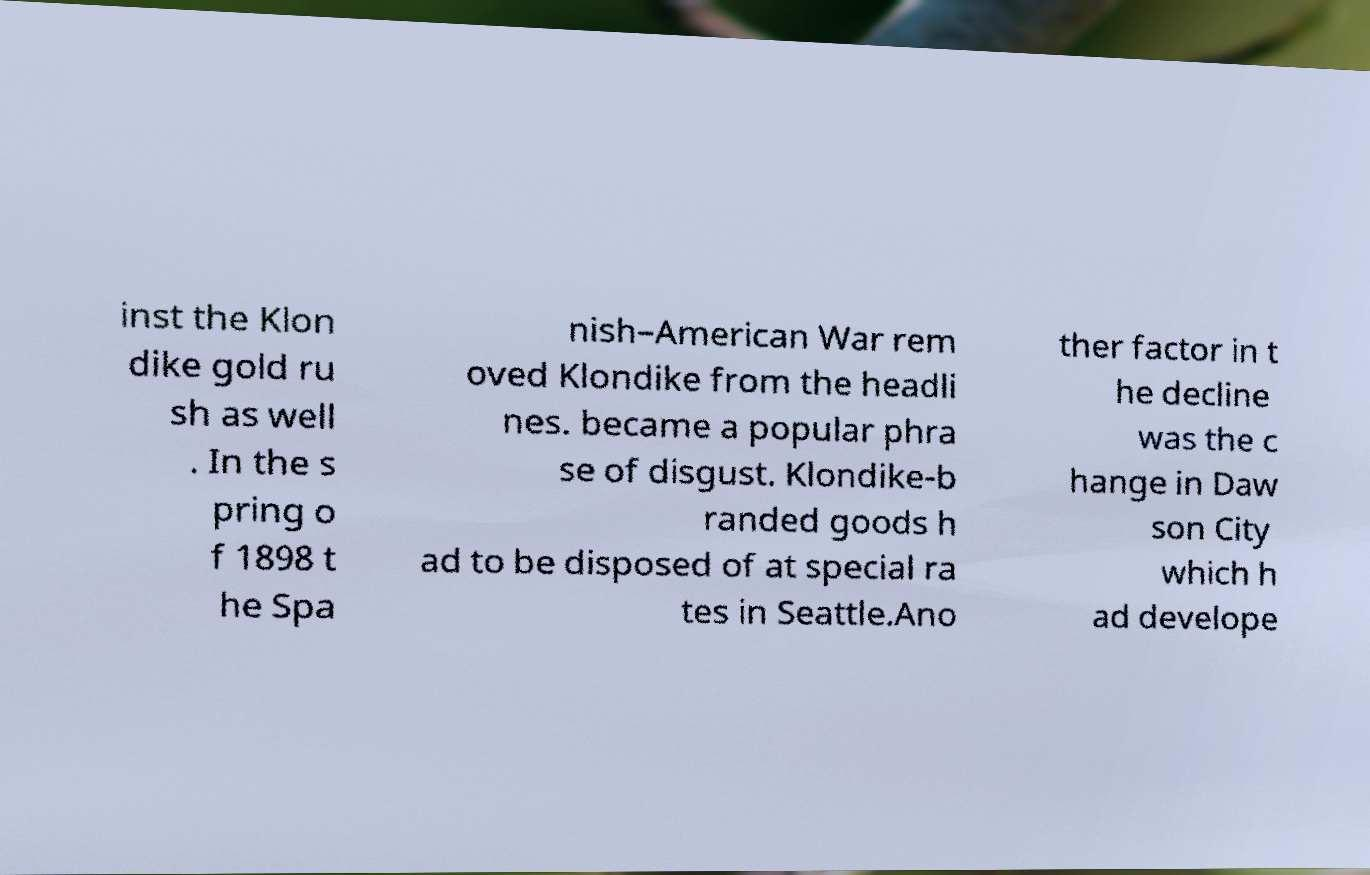Please identify and transcribe the text found in this image. inst the Klon dike gold ru sh as well . In the s pring o f 1898 t he Spa nish–American War rem oved Klondike from the headli nes. became a popular phra se of disgust. Klondike-b randed goods h ad to be disposed of at special ra tes in Seattle.Ano ther factor in t he decline was the c hange in Daw son City which h ad develope 